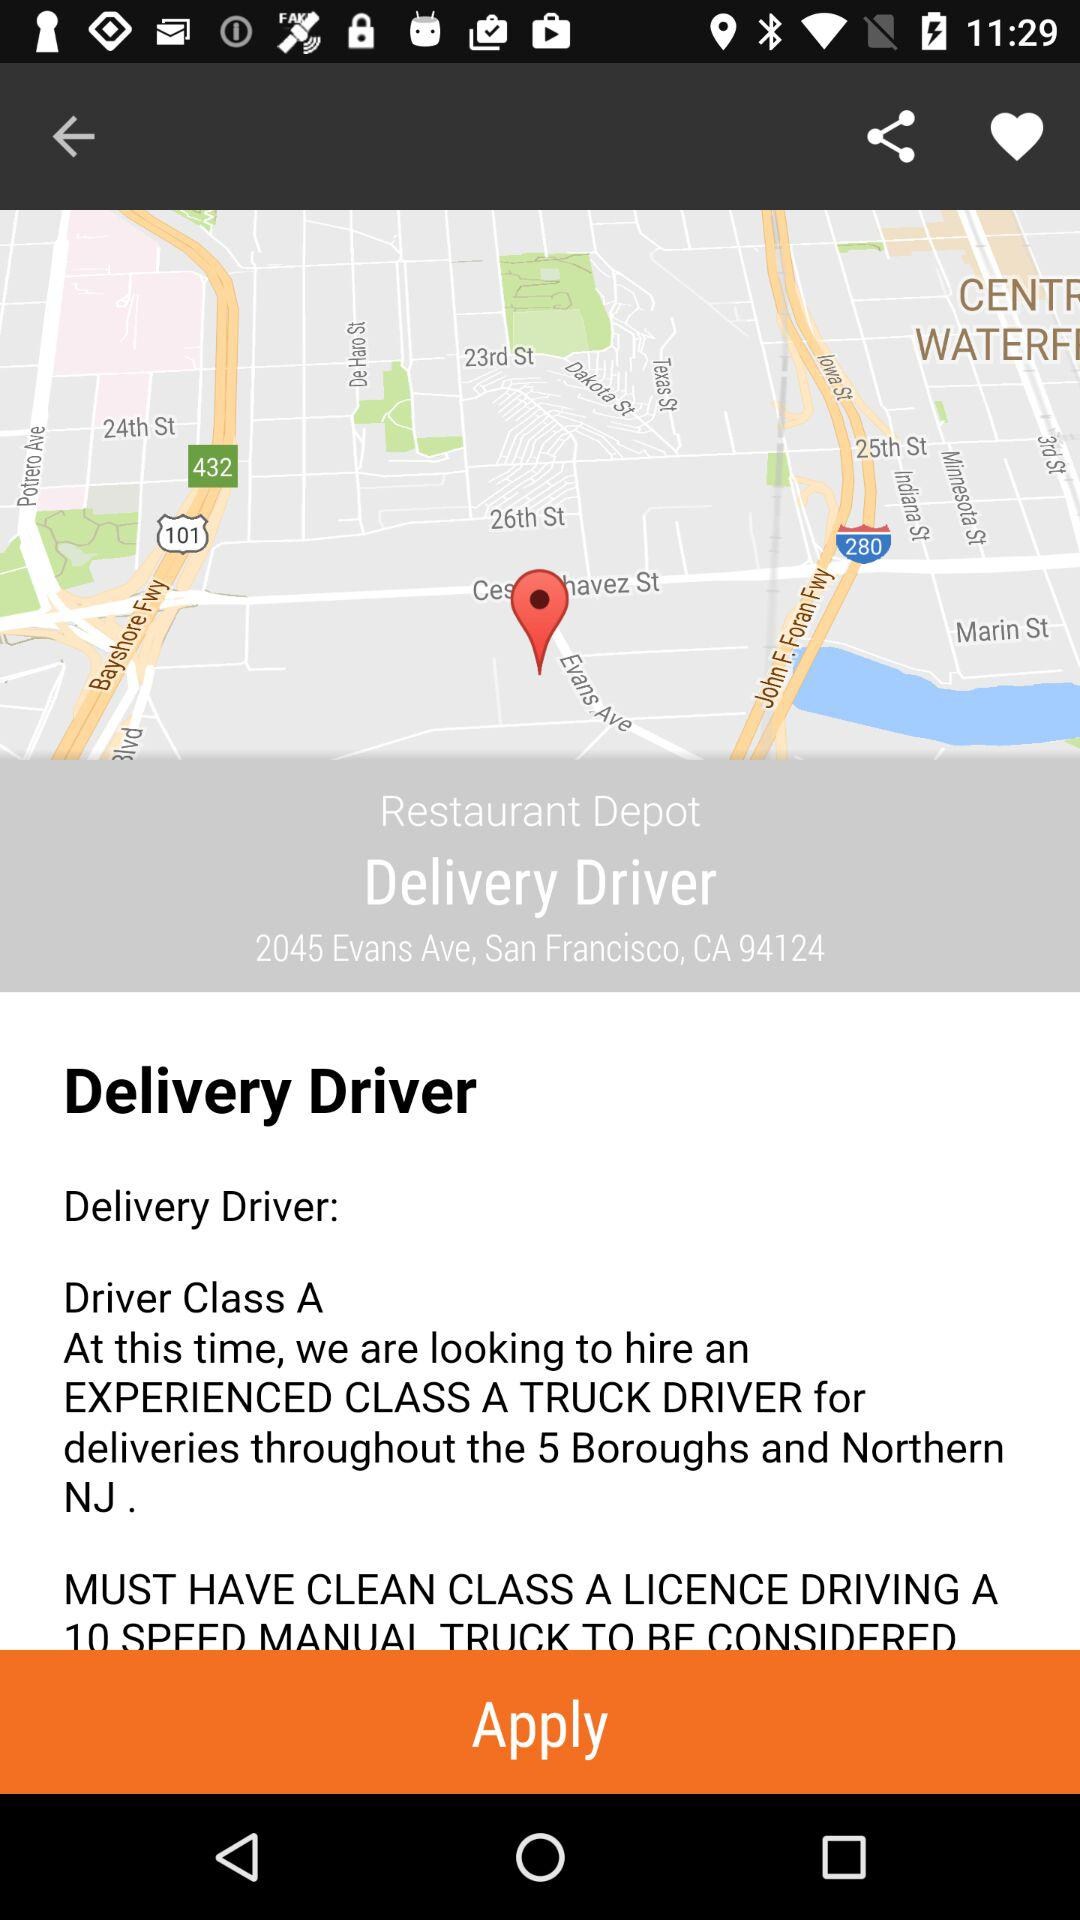What is the delivery city pincode? The delivery city pincode is 94124. 